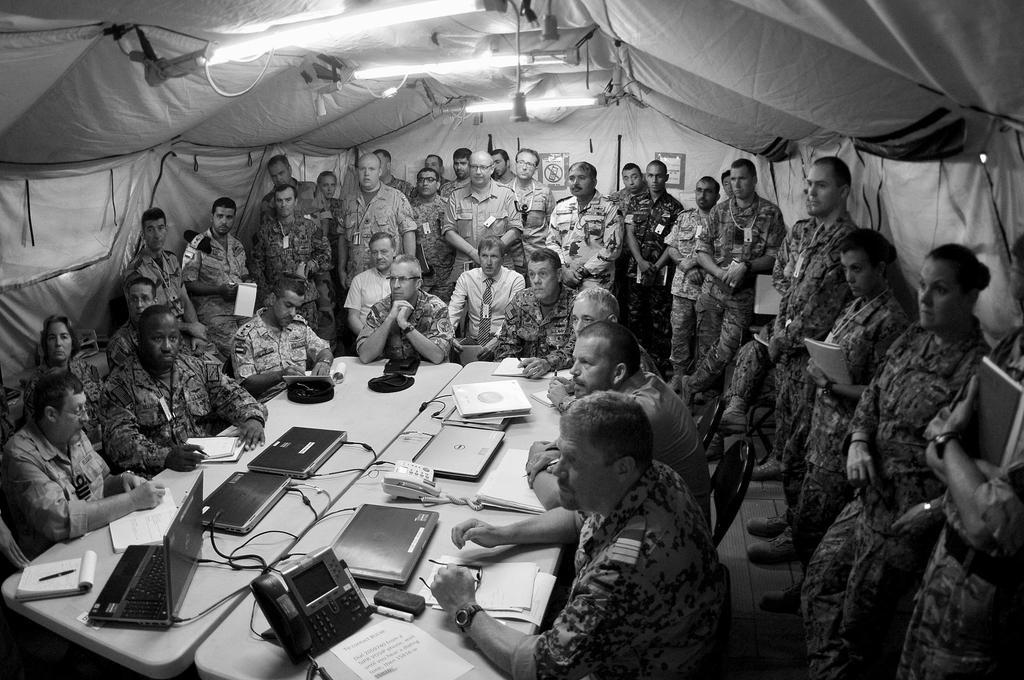Could you give a brief overview of what you see in this image? As we can see in the image there is tent, lights, group of people wearing army dresses and there are tables. On tables there are laptops, phone, papers, books and pens. 